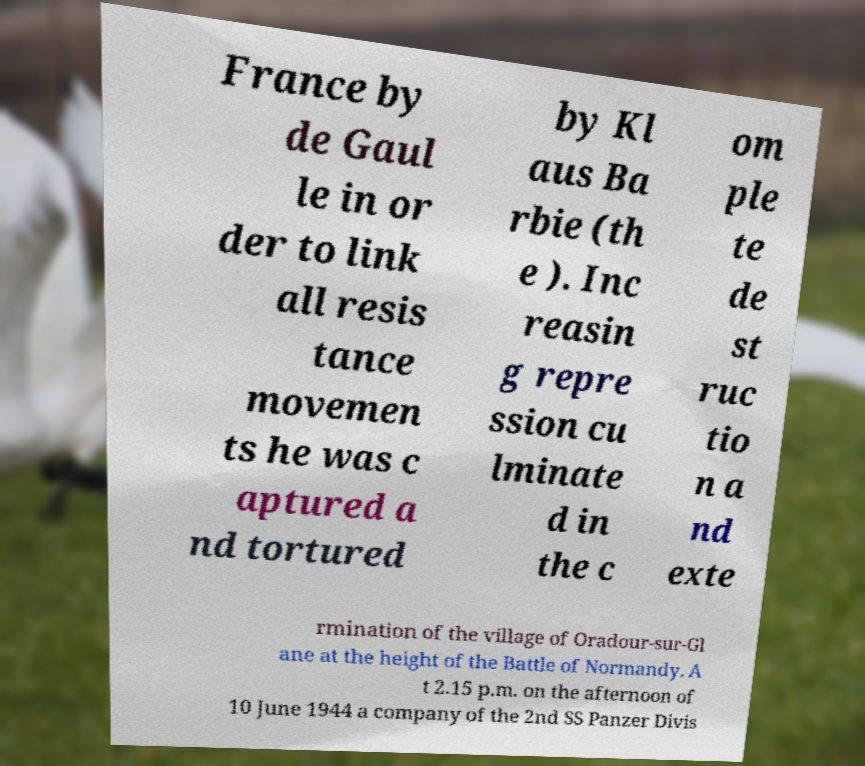Could you extract and type out the text from this image? France by de Gaul le in or der to link all resis tance movemen ts he was c aptured a nd tortured by Kl aus Ba rbie (th e ). Inc reasin g repre ssion cu lminate d in the c om ple te de st ruc tio n a nd exte rmination of the village of Oradour-sur-Gl ane at the height of the Battle of Normandy. A t 2.15 p.m. on the afternoon of 10 June 1944 a company of the 2nd SS Panzer Divis 